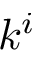<formula> <loc_0><loc_0><loc_500><loc_500>k ^ { i }</formula> 